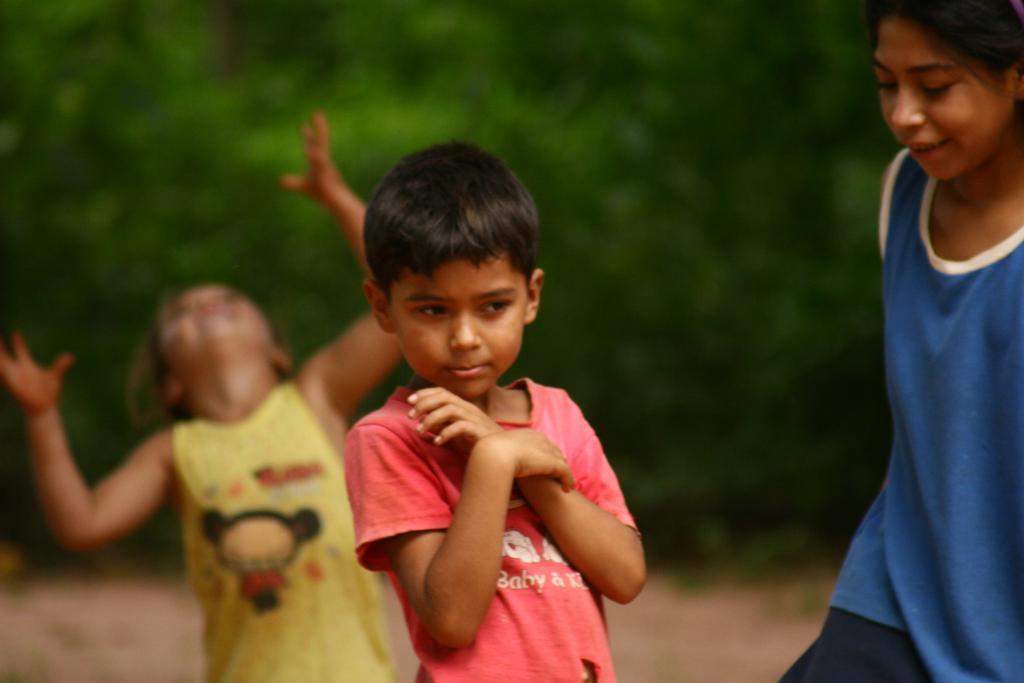Can you describe this image briefly? In the image in the center we can see three kids were standing and they were smiling. In the background we can see trees. 